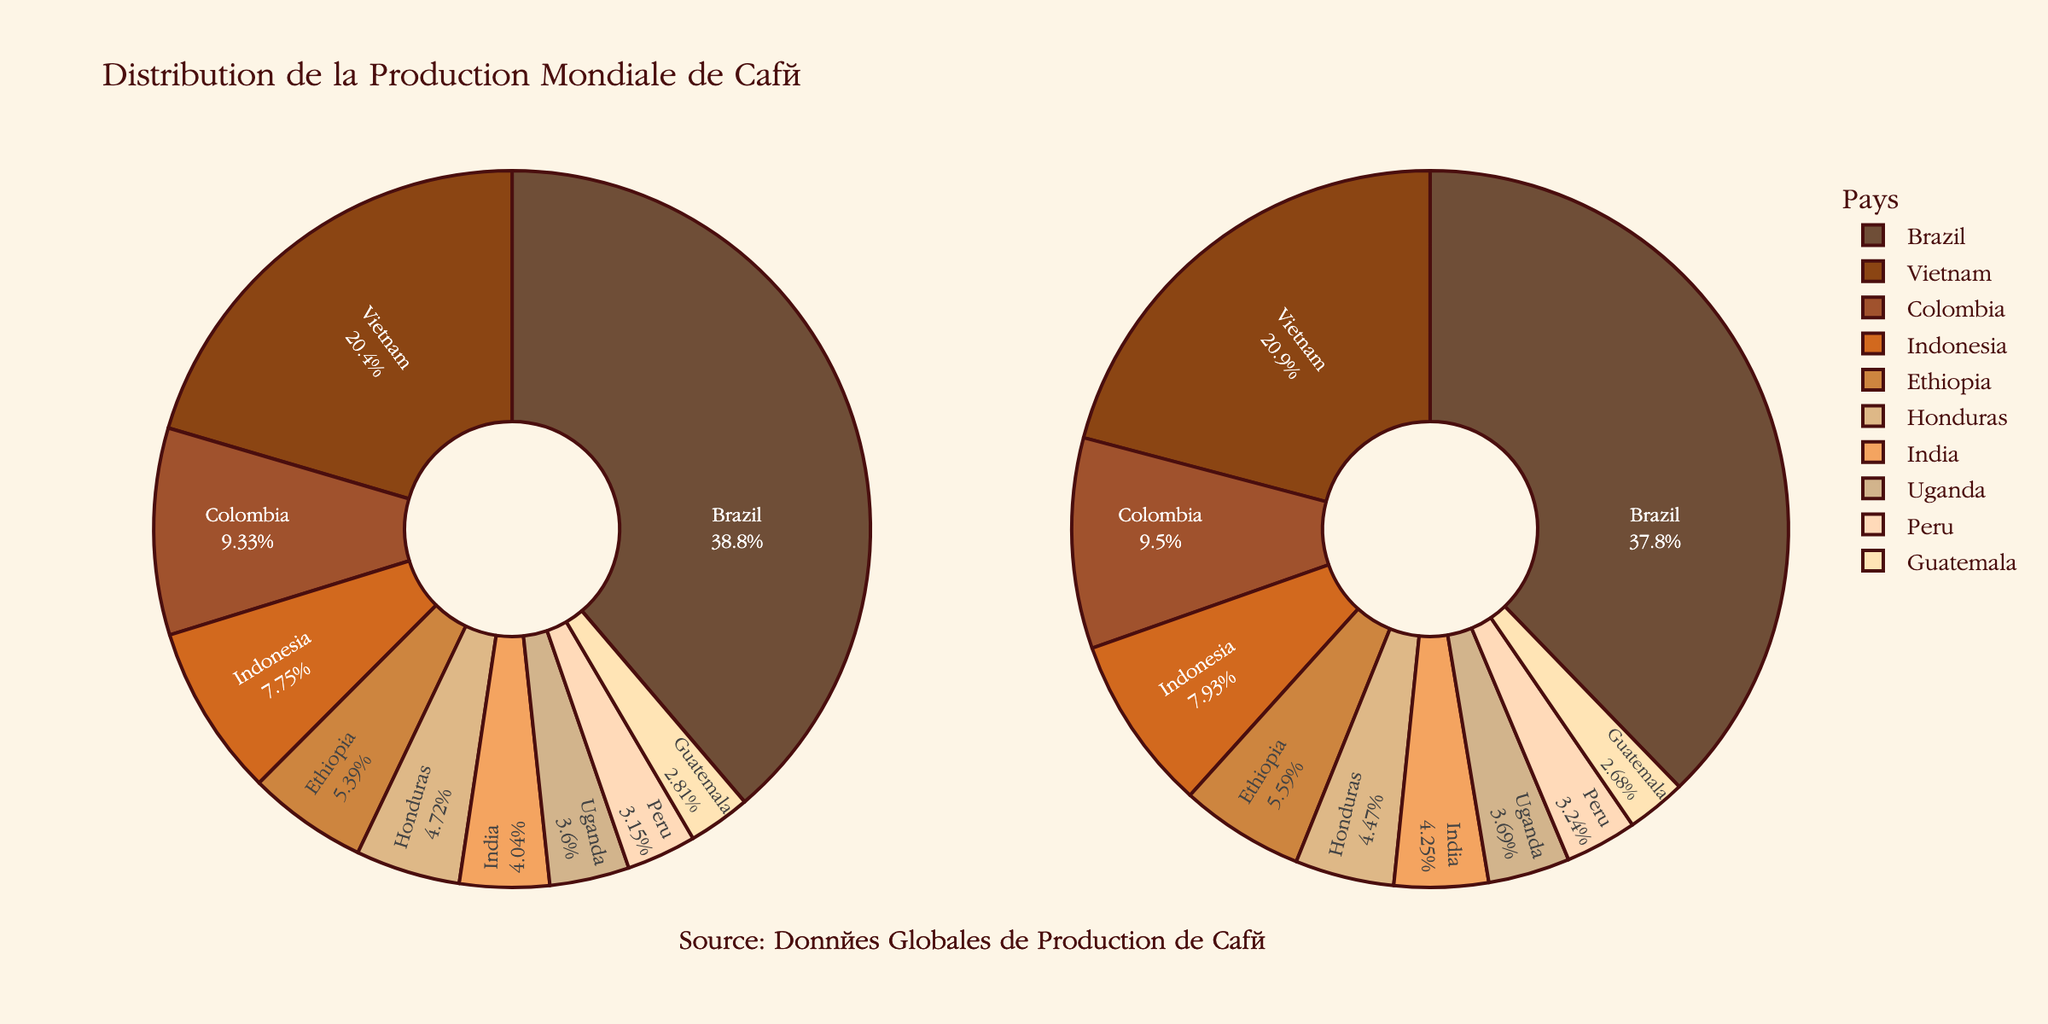What is the title of the plot? The plot's title is displayed at the top and reads, "Distribution de la Production Mondiale de Café" which translates to "Distribution of Global Coffee Production".
Answer: Distribution de la Production Mondiale de Café Which country had the highest coffee production percentage in 2021? By observing the pie chart for 2021, the largest segment represents Brazil, indicating it had the highest production percentage.
Answer: Brazil How did the production percentage of Brazil change from 2020 to 2021? Look at the pie chart segments for Brazil in both 2020 and 2021. Brazil's percentage decreased from 34.5% in 2020 to 33.8% in 2021. Calculate the difference: 34.5% - 33.8% = 0.7%.
Answer: Decreased by 0.7% Which country had the smallest change in production percentage between the two years? Compare the segments for each country between the two years. Guatemala had the smallest change, going from 2.5% in 2020 to 2.4% in 2021, a difference of 0.1%.
Answer: Guatemala What are the top three coffee-producing countries in 2020 and 2021? By looking at the largest segments in both pie charts, we see that the top three countries in both years are Brazil, Vietnam, and Colombia.
Answer: Brazil, Vietnam, Colombia Which country saw an increase in its production percentage from 2020 to 2021? Look at each country's segments for both years to identify increases. Vietnam, Colombia, Indonesia, Ethiopia, India, Uganda, and Peru all saw increases in their production percentages.
Answer: Vietnam, Colombia, Indonesia, Ethiopia, India, Uganda, Peru Among the top five coffee-producing countries in 2021, what was the combined production percentage? Sum the production percentages of Brazil (33.8%), Vietnam (18.7%), Colombia (8.5%), Indonesia (7.1%), and Ethiopia (5.0%). Combined production percentage: 33.8% + 18.7% + 8.5% + 7.1% + 5.0% = 73.1%.
Answer: 73.1% Which two countries had an equal production percentage in 2020? By comparing the sizes of the sectors, we see that no two countries had exactly the same production percentage in 2020.
Answer: None What color represents India in the pie charts? Look at the color legend associated with each country in the pie charts. India is represented by a light tan color.
Answer: Light tan How did Ethiopia's percentage change between the years 2020 and 2021? Look at the pie chart segments for Ethiopia in both years. Ethiopia's percentage increased from 4.8% in 2020 to 5.0% in 2021.
Answer: Increased by 0.2% 